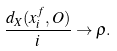Convert formula to latex. <formula><loc_0><loc_0><loc_500><loc_500>\frac { d _ { X } ( x _ { i } ^ { f } , O ) } { i } \to \rho .</formula> 